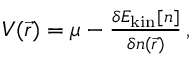<formula> <loc_0><loc_0><loc_500><loc_500>\begin{array} { r } { V ( \vec { r } ) = \mu - \frac { \delta E _ { k i n } [ n ] } { \delta n ( \vec { r } ) } \, , } \end{array}</formula> 